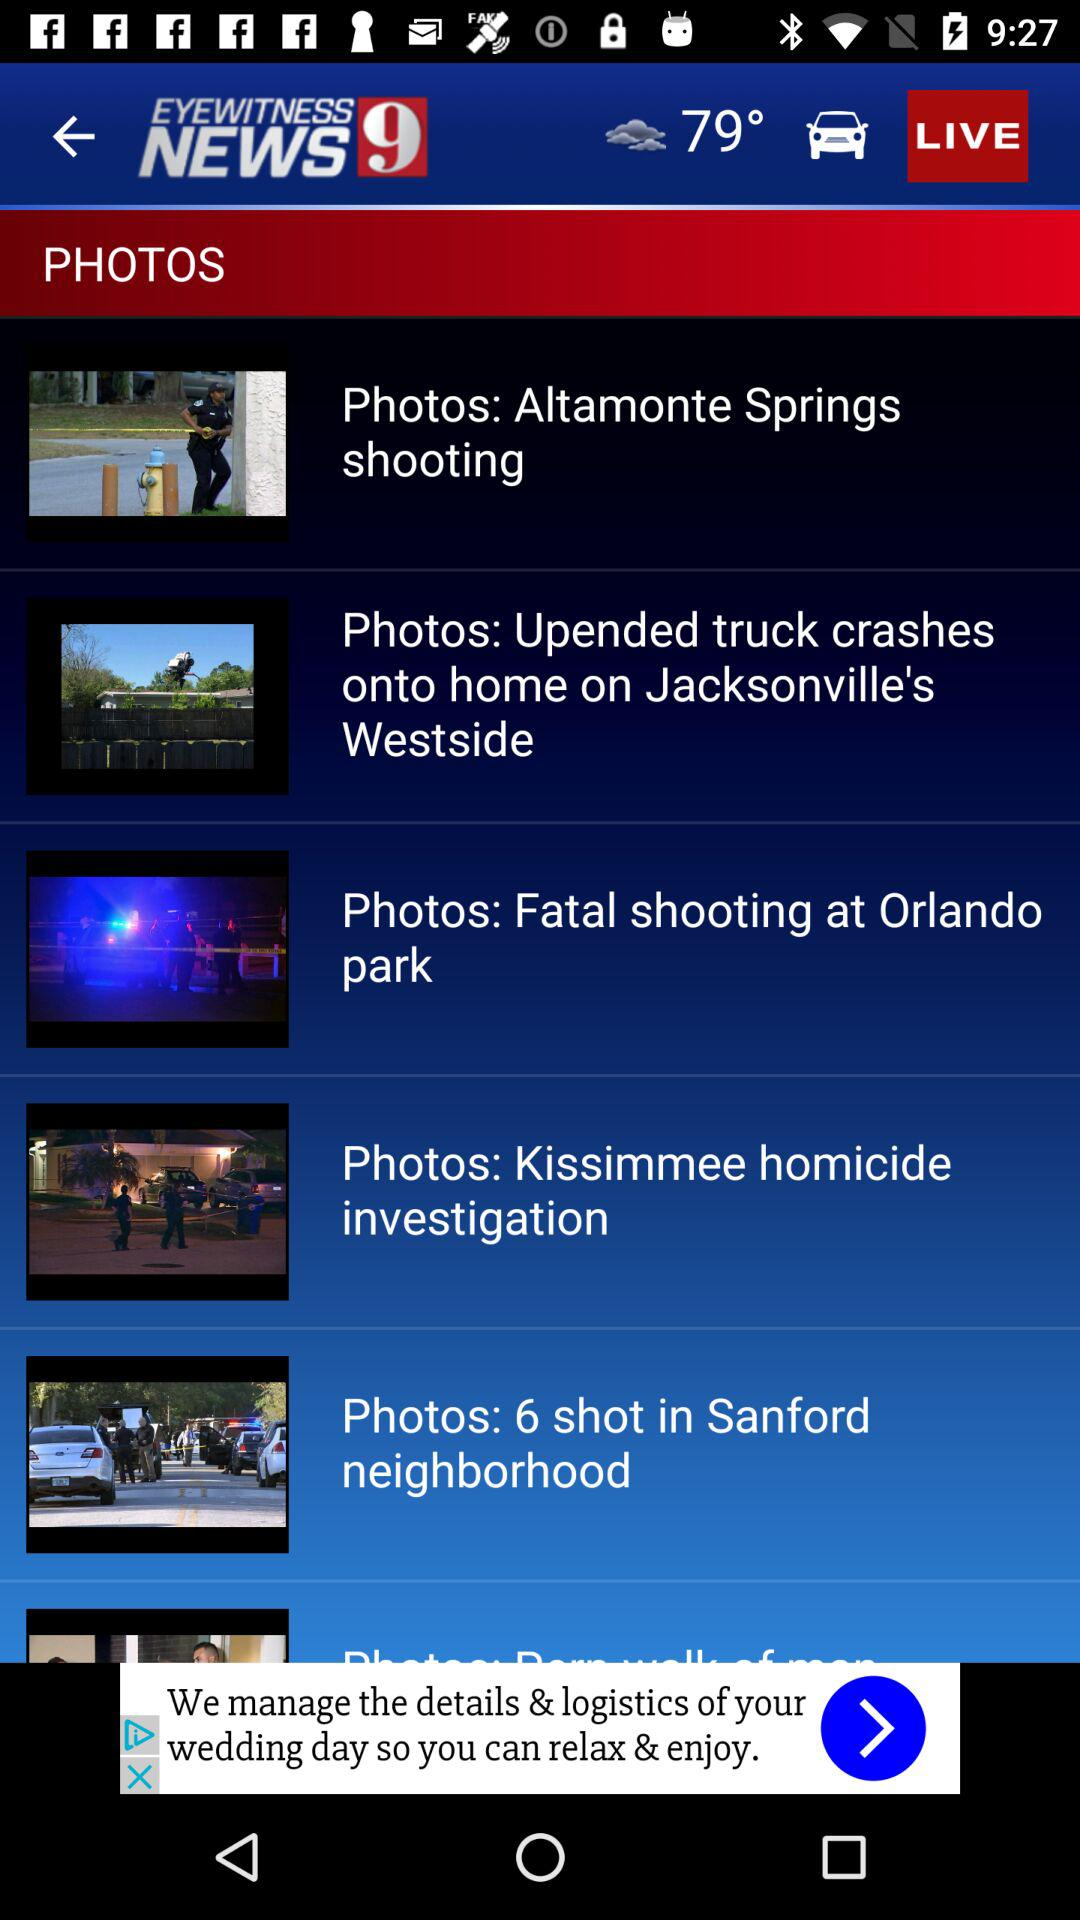Which photo has been selected?
When the provided information is insufficient, respond with <no answer>. <no answer> 